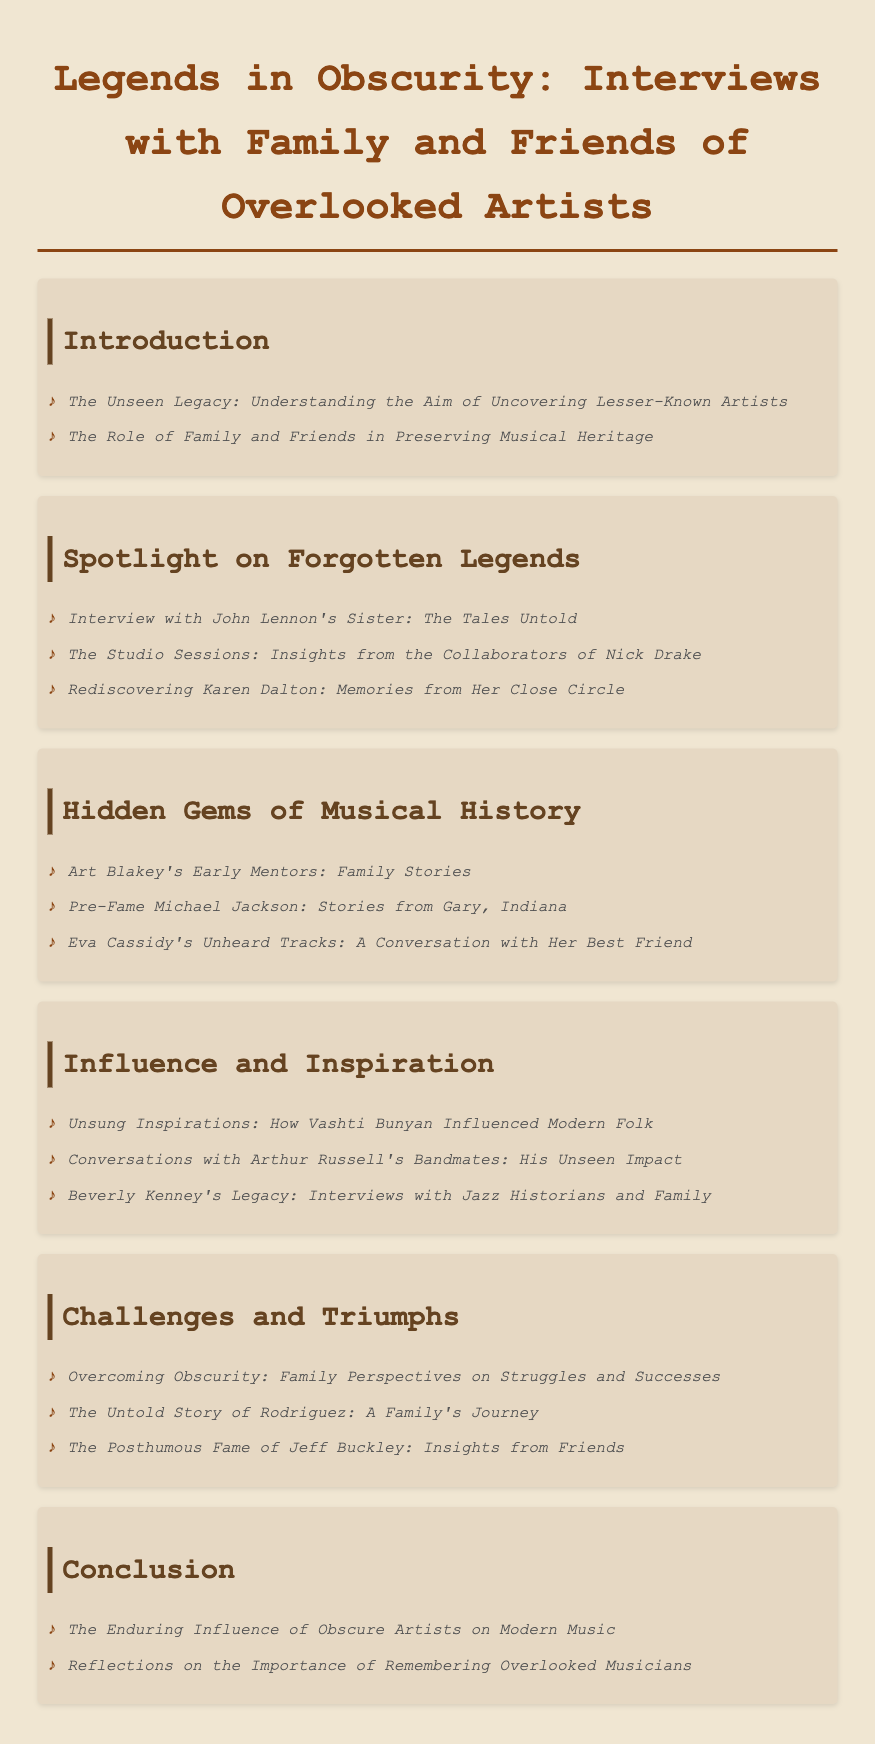What is the title of the document? The title of the document is found in the header, highlighting the subject matter it covers.
Answer: Legends in Obscurity: Interviews with Family and Friends of Overlooked Artists How many sections are in the "Challenges and Triumphs" chapter? The "Challenges and Triumphs" chapter is one of the sections that lists specific interviews within it, and counting them gives the answer.
Answer: 3 Who was interviewed about their early mentors? The specific artist discussed in the interview indicates the focal point of that section.
Answer: Art Blakey What is the focus of the introduction section? The introduction discusses the purpose and context of the document, which is fundamental to its structure.
Answer: Understanding the Aim of Uncovering Lesser-Known Artists Which artist has a section on pre-fame stories? This artist is mentioned in connection with stories from their early life, indicating their historical significance.
Answer: Michael Jackson How many interviews are in the "Spotlight on Forgotten Legends" chapter? Counting the listed interviews in this chapter provides a clear answer about its content density.
Answer: 3 What type of legacy is explored in the conclusion? The conclusion discusses a particular type of influence that obscure artists have had over time.
Answer: Enduring Influence Who provides insights in the section about Jeff Buckley? This indicates who reflects on another artist's posthumous fame, adding perspective to the document.
Answer: Friends 